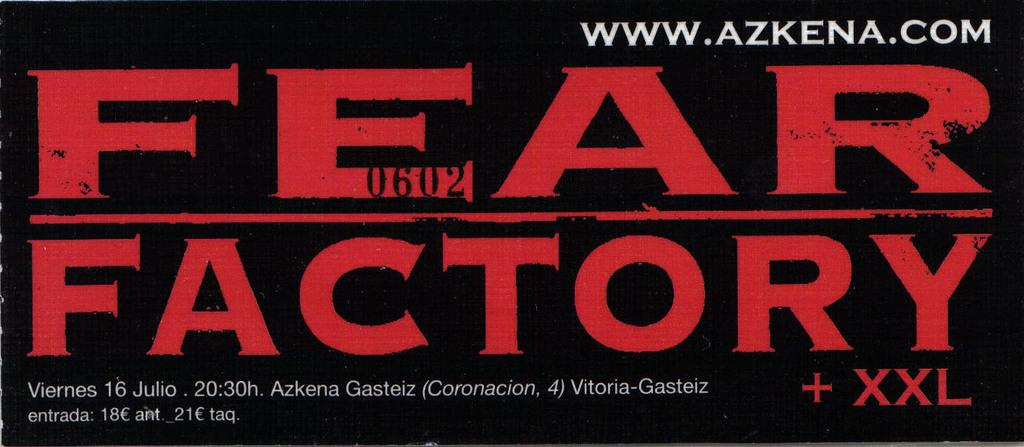<image>
Create a compact narrative representing the image presented. a black banner that says 'fear factory' on it 